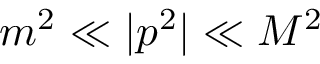Convert formula to latex. <formula><loc_0><loc_0><loc_500><loc_500>m ^ { 2 } \ll | p ^ { 2 } | \ll M ^ { 2 }</formula> 